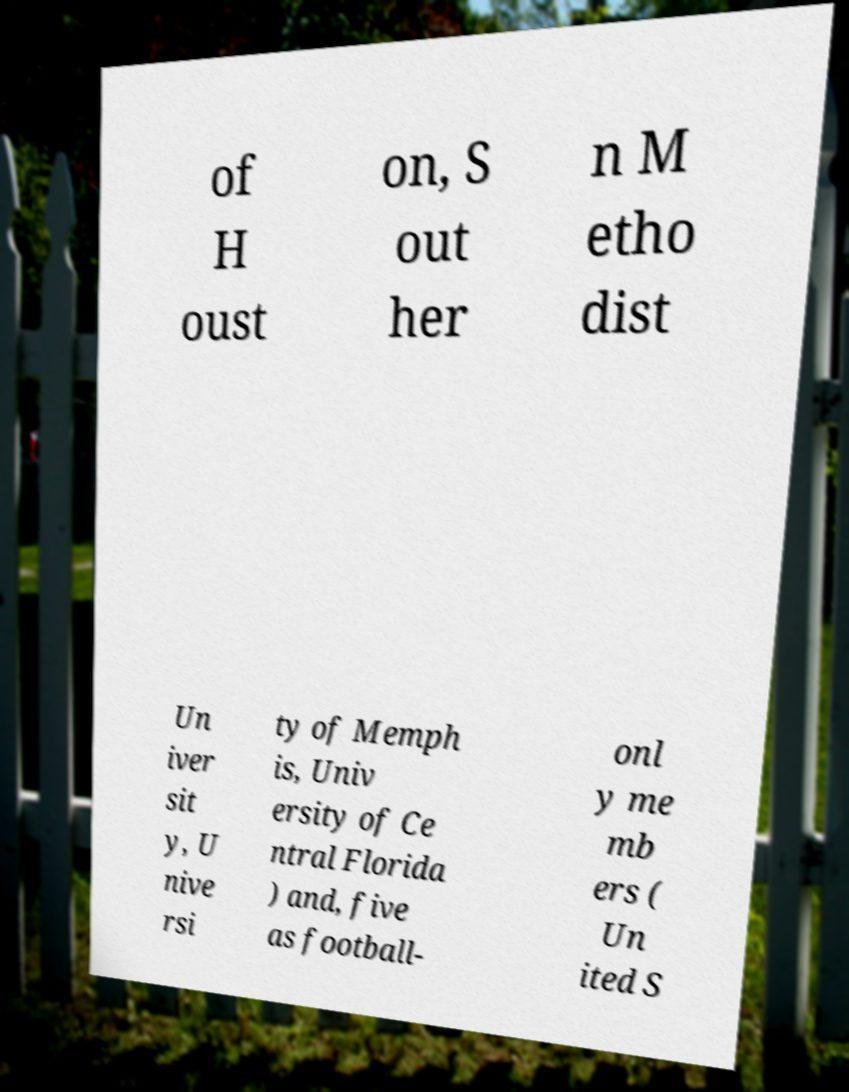I need the written content from this picture converted into text. Can you do that? of H oust on, S out her n M etho dist Un iver sit y, U nive rsi ty of Memph is, Univ ersity of Ce ntral Florida ) and, five as football- onl y me mb ers ( Un ited S 